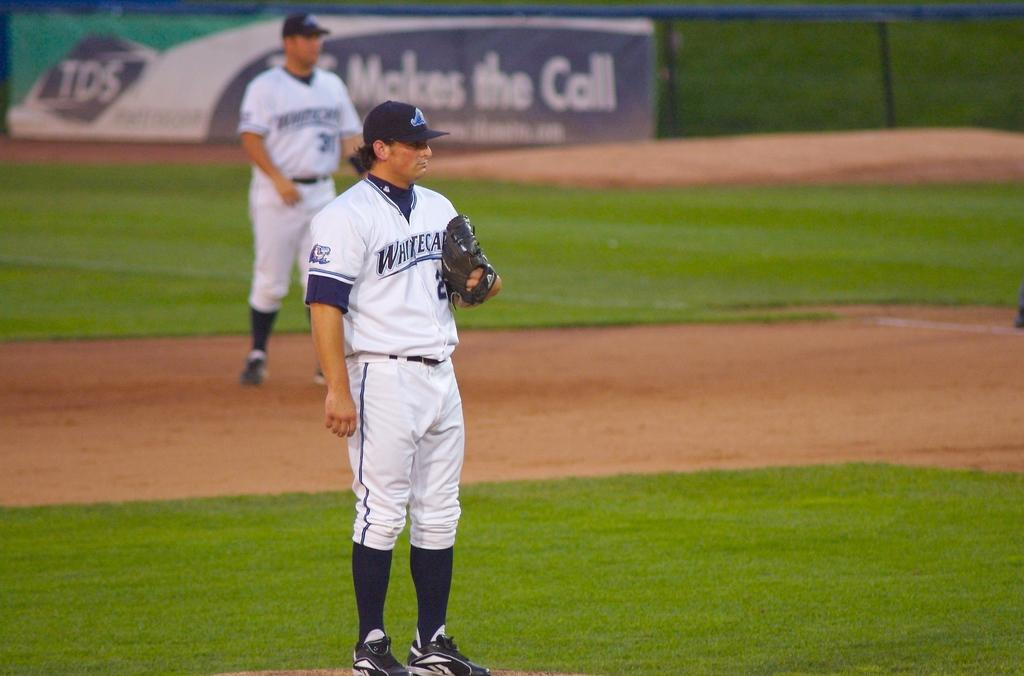<image>
Offer a succinct explanation of the picture presented. a baseball field with players with jerseys saying White in front of TDS ad 